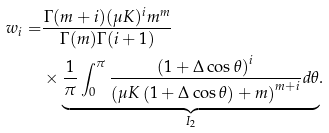Convert formula to latex. <formula><loc_0><loc_0><loc_500><loc_500>w _ { i } = & \frac { \Gamma ( m + i ) ( \mu K ) ^ { i } m ^ { m } } { \Gamma ( m ) \Gamma ( i + 1 ) } \\ & \times \underset { I _ { 2 } } { \underbrace { \frac { 1 } { \pi } \int _ { 0 } ^ { \pi } \frac { \left ( 1 + \Delta \cos \theta \right ) ^ { i } } { \left ( \mu K \left ( 1 + \Delta \cos \theta \right ) + m \right ) ^ { m + i } } d \theta } } .</formula> 